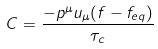<formula> <loc_0><loc_0><loc_500><loc_500>C = { \frac { - { p ^ { \mu } u _ { \mu } ( f - f _ { e q } ) } } { \tau _ { c } } }</formula> 